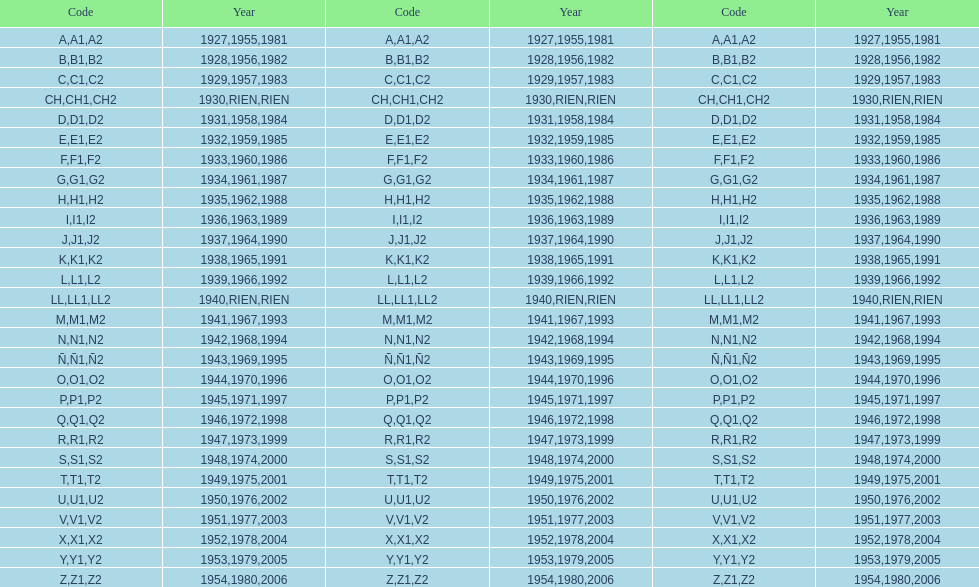Is the e-code lesser than 1950? Yes. 